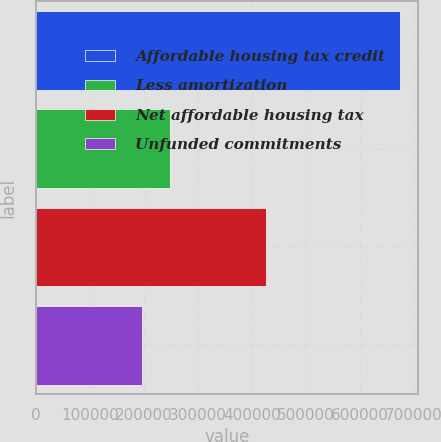Convert chart. <chart><loc_0><loc_0><loc_500><loc_500><bar_chart><fcel>Affordable housing tax credit<fcel>Less amortization<fcel>Net affordable housing tax<fcel>Unfunded commitments<nl><fcel>674157<fcel>248657<fcel>425500<fcel>196001<nl></chart> 